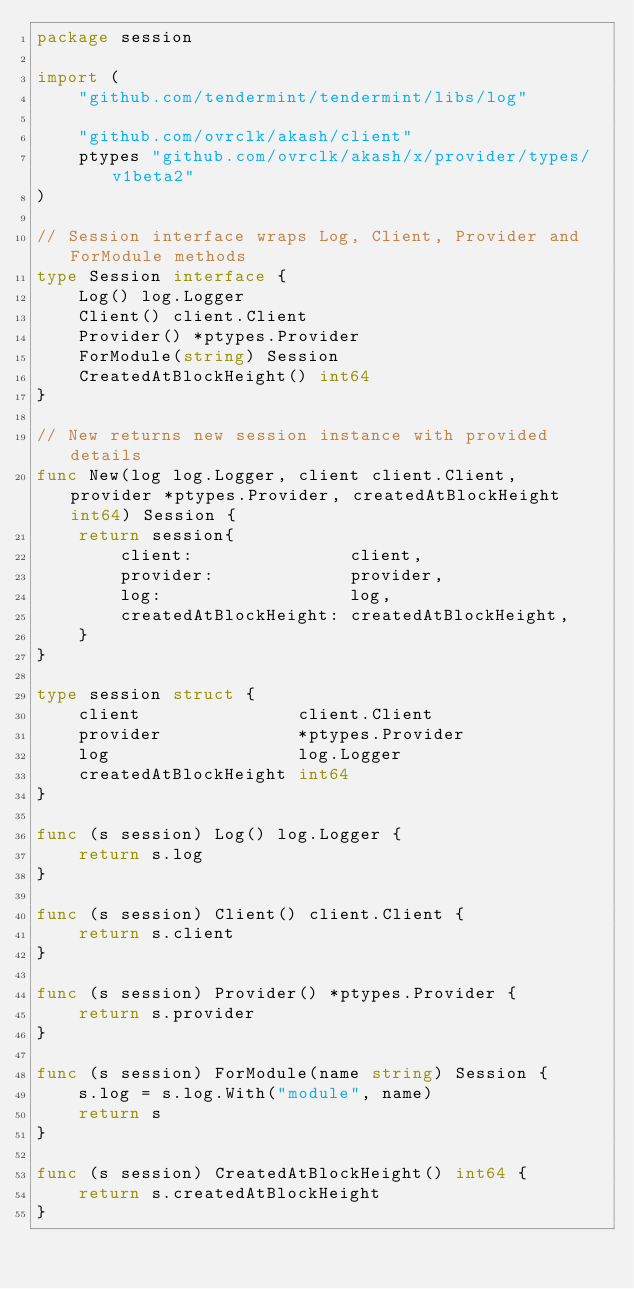<code> <loc_0><loc_0><loc_500><loc_500><_Go_>package session

import (
	"github.com/tendermint/tendermint/libs/log"

	"github.com/ovrclk/akash/client"
	ptypes "github.com/ovrclk/akash/x/provider/types/v1beta2"
)

// Session interface wraps Log, Client, Provider and ForModule methods
type Session interface {
	Log() log.Logger
	Client() client.Client
	Provider() *ptypes.Provider
	ForModule(string) Session
	CreatedAtBlockHeight() int64
}

// New returns new session instance with provided details
func New(log log.Logger, client client.Client, provider *ptypes.Provider, createdAtBlockHeight int64) Session {
	return session{
		client:               client,
		provider:             provider,
		log:                  log,
		createdAtBlockHeight: createdAtBlockHeight,
	}
}

type session struct {
	client               client.Client
	provider             *ptypes.Provider
	log                  log.Logger
	createdAtBlockHeight int64
}

func (s session) Log() log.Logger {
	return s.log
}

func (s session) Client() client.Client {
	return s.client
}

func (s session) Provider() *ptypes.Provider {
	return s.provider
}

func (s session) ForModule(name string) Session {
	s.log = s.log.With("module", name)
	return s
}

func (s session) CreatedAtBlockHeight() int64 {
	return s.createdAtBlockHeight
}
</code> 